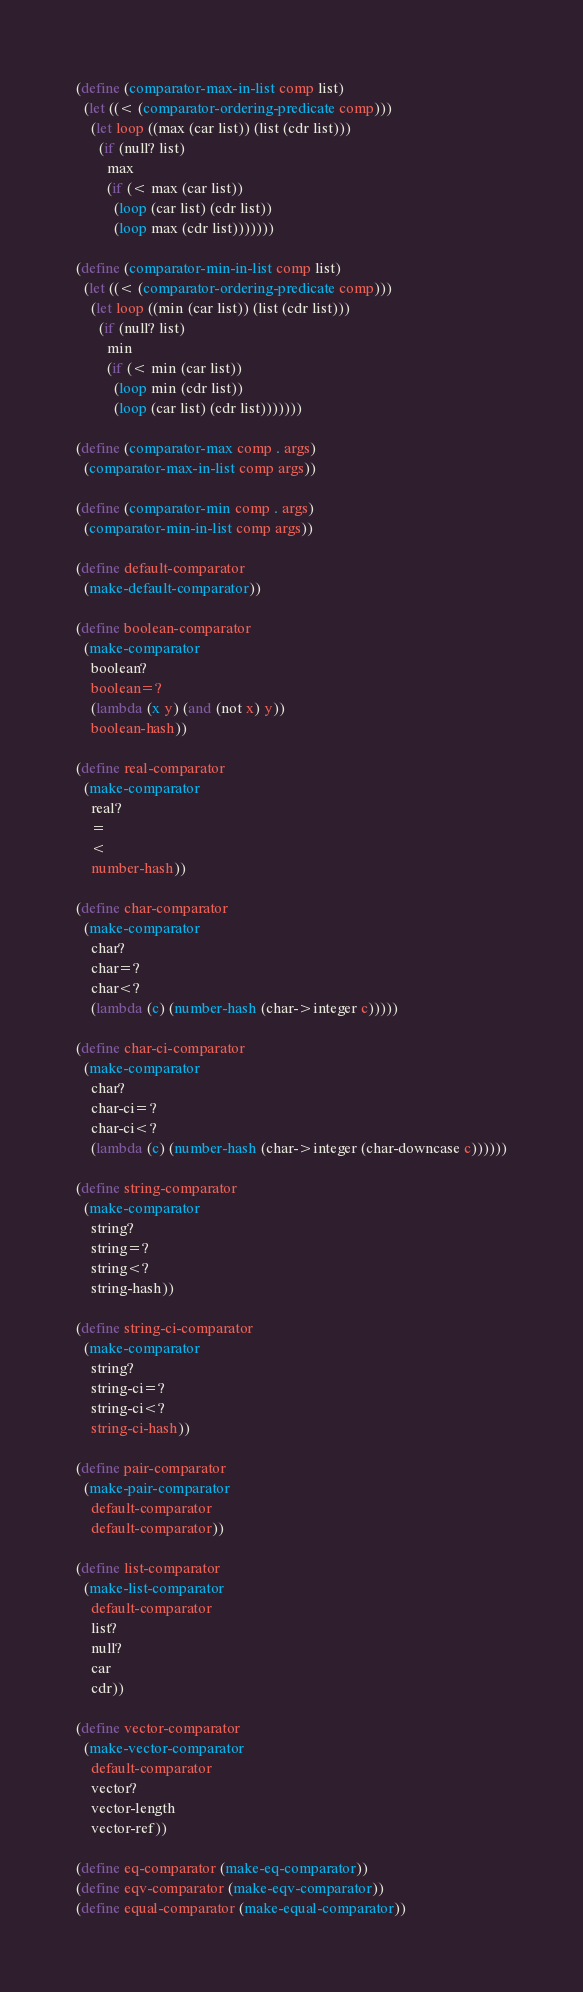Convert code to text. <code><loc_0><loc_0><loc_500><loc_500><_Scheme_>(define (comparator-max-in-list comp list)
  (let ((< (comparator-ordering-predicate comp)))
    (let loop ((max (car list)) (list (cdr list)))
      (if (null? list)
        max
        (if (< max (car list))
          (loop (car list) (cdr list))
          (loop max (cdr list)))))))

(define (comparator-min-in-list comp list)
  (let ((< (comparator-ordering-predicate comp)))
    (let loop ((min (car list)) (list (cdr list)))
      (if (null? list)
        min
        (if (< min (car list))
          (loop min (cdr list))
          (loop (car list) (cdr list)))))))

(define (comparator-max comp . args)
  (comparator-max-in-list comp args))

(define (comparator-min comp . args)
  (comparator-min-in-list comp args))

(define default-comparator
  (make-default-comparator))

(define boolean-comparator
  (make-comparator
    boolean?
    boolean=?
    (lambda (x y) (and (not x) y))
    boolean-hash))

(define real-comparator
  (make-comparator
    real?
    =
    <
    number-hash))

(define char-comparator
  (make-comparator
    char?
    char=?
    char<?
    (lambda (c) (number-hash (char->integer c)))))

(define char-ci-comparator
  (make-comparator
    char?
    char-ci=?
    char-ci<?
    (lambda (c) (number-hash (char->integer (char-downcase c))))))

(define string-comparator
  (make-comparator
    string?
    string=?
    string<?
    string-hash))

(define string-ci-comparator
  (make-comparator
    string?
    string-ci=?
    string-ci<?
    string-ci-hash))

(define pair-comparator
  (make-pair-comparator
    default-comparator
    default-comparator))

(define list-comparator
  (make-list-comparator
    default-comparator
    list?
    null?
    car
    cdr))

(define vector-comparator
  (make-vector-comparator
    default-comparator
    vector?
    vector-length
    vector-ref))

(define eq-comparator (make-eq-comparator))
(define eqv-comparator (make-eqv-comparator))
(define equal-comparator (make-equal-comparator))
</code> 